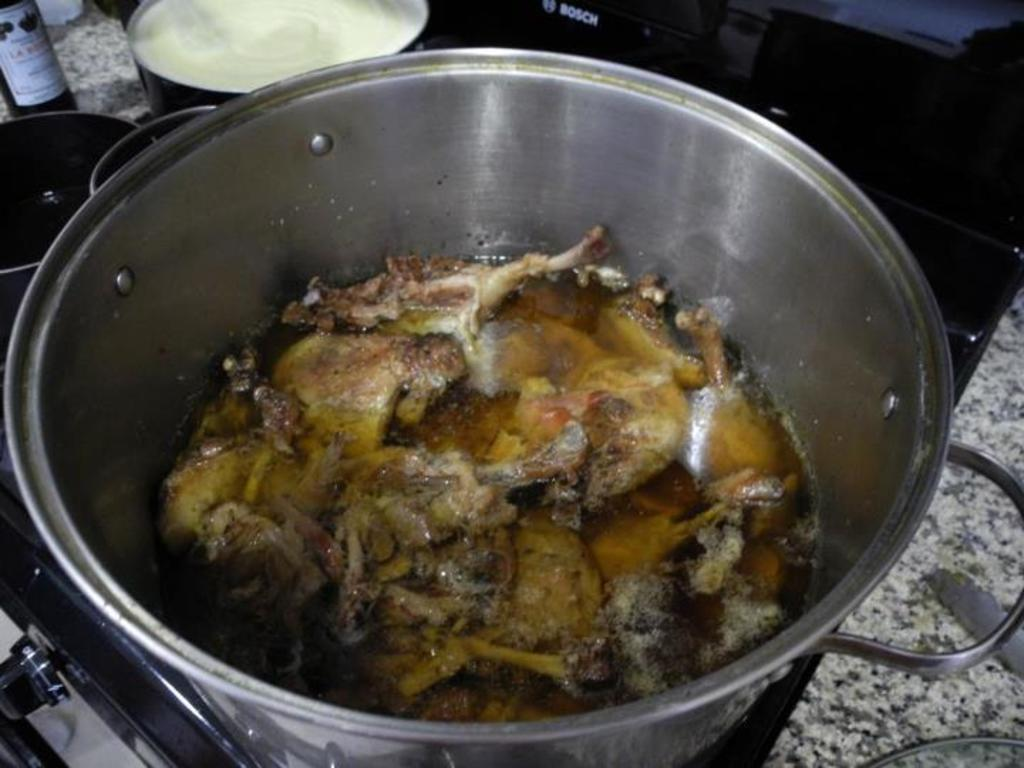What is located at the bottom of the image? There is a stove at the bottom of the image. What is being cooked on the stove? There is a vessel containing meat placed on the stove. What type of containers are visible in the image? There are bowls visible in the image. What is placed on the counter top? There is a bottle placed on the counter top. What type of chess game is being played in the image? There is no chess game present in the image. What date is shown on the calendar in the image? There is no calendar present in the image. 